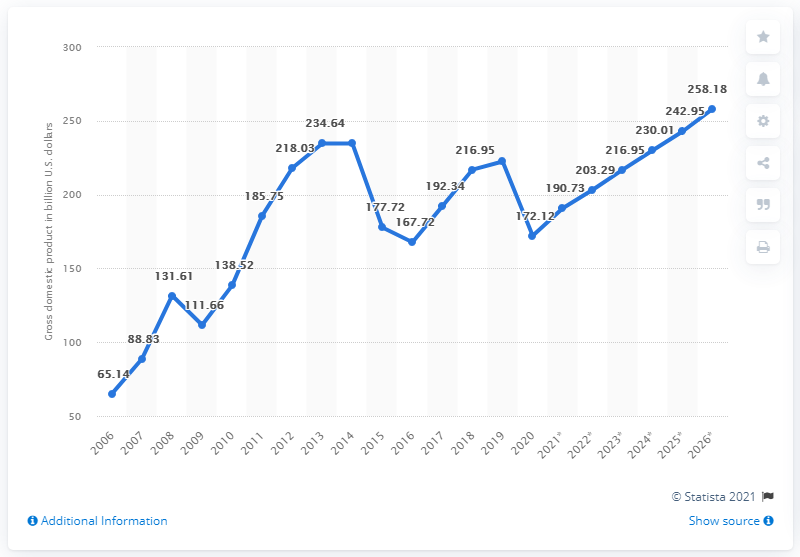Highlight a few significant elements in this photo. In 2020, the gross domestic product (GDP) of Iraq was 172.12 billion dollars. 